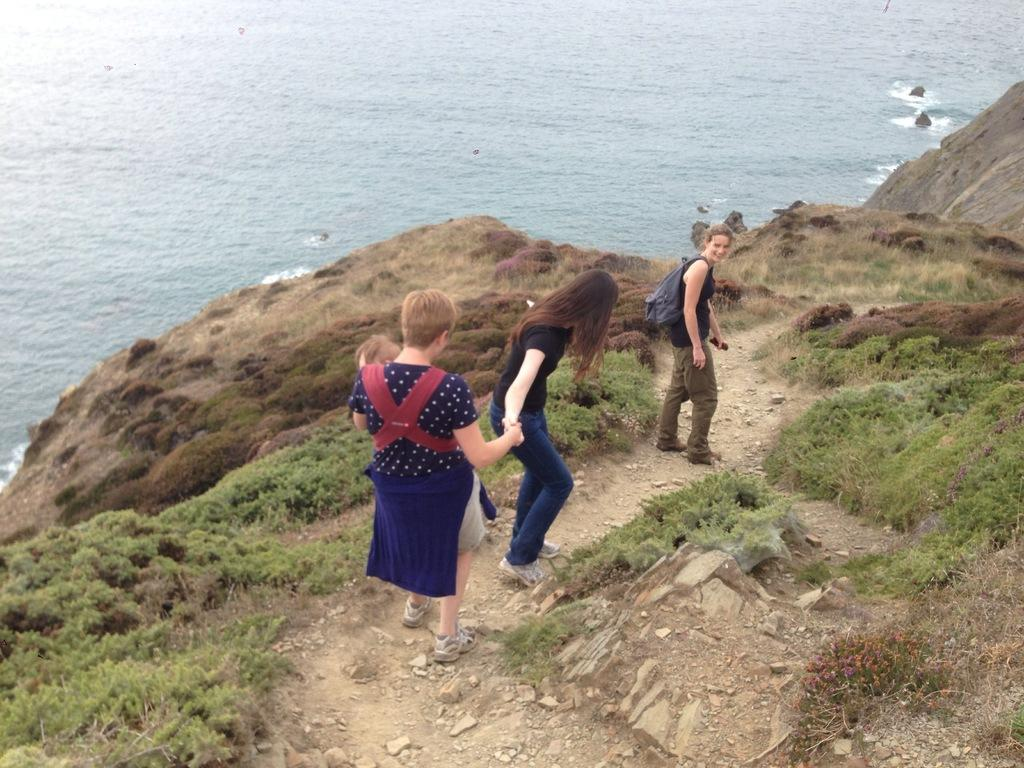What type of terrain is depicted in the image? There is a path on a hill in the image, with grass and rocks. What are the people in the image doing? There are people walking on the hill path. What can be seen in the background of the image? Water is visible in the background of the image. Where is the nearest hospital to the hill path in the image? There is no information about the location of a hospital in the image, as it only shows a hill path with people walking on it and water in the background. 